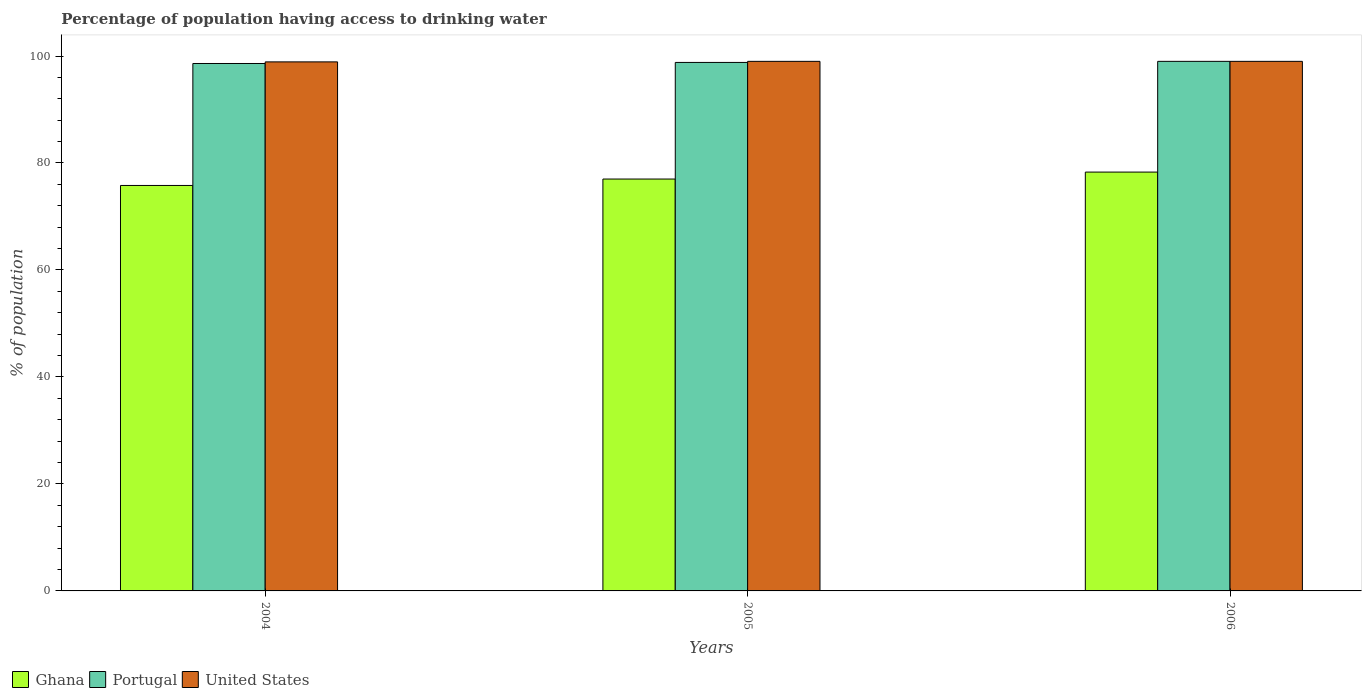How many different coloured bars are there?
Your answer should be compact. 3. How many groups of bars are there?
Your answer should be very brief. 3. Are the number of bars per tick equal to the number of legend labels?
Provide a short and direct response. Yes. How many bars are there on the 2nd tick from the right?
Ensure brevity in your answer.  3. What is the percentage of population having access to drinking water in Portugal in 2005?
Give a very brief answer. 98.8. Across all years, what is the minimum percentage of population having access to drinking water in Portugal?
Ensure brevity in your answer.  98.6. In which year was the percentage of population having access to drinking water in United States minimum?
Your response must be concise. 2004. What is the total percentage of population having access to drinking water in United States in the graph?
Your response must be concise. 296.9. What is the difference between the percentage of population having access to drinking water in United States in 2005 and that in 2006?
Make the answer very short. 0. What is the difference between the percentage of population having access to drinking water in Portugal in 2006 and the percentage of population having access to drinking water in United States in 2004?
Offer a very short reply. 0.1. What is the average percentage of population having access to drinking water in Ghana per year?
Offer a very short reply. 77.03. In the year 2005, what is the difference between the percentage of population having access to drinking water in Portugal and percentage of population having access to drinking water in United States?
Offer a terse response. -0.2. What is the ratio of the percentage of population having access to drinking water in Ghana in 2004 to that in 2005?
Offer a terse response. 0.98. Is the percentage of population having access to drinking water in Ghana in 2004 less than that in 2005?
Make the answer very short. Yes. Is the difference between the percentage of population having access to drinking water in Portugal in 2005 and 2006 greater than the difference between the percentage of population having access to drinking water in United States in 2005 and 2006?
Ensure brevity in your answer.  No. What is the difference between the highest and the second highest percentage of population having access to drinking water in United States?
Provide a short and direct response. 0. What is the difference between the highest and the lowest percentage of population having access to drinking water in Ghana?
Ensure brevity in your answer.  2.5. What does the 3rd bar from the left in 2005 represents?
Provide a short and direct response. United States. Is it the case that in every year, the sum of the percentage of population having access to drinking water in United States and percentage of population having access to drinking water in Portugal is greater than the percentage of population having access to drinking water in Ghana?
Provide a succinct answer. Yes. How many bars are there?
Provide a short and direct response. 9. How many years are there in the graph?
Your answer should be very brief. 3. What is the difference between two consecutive major ticks on the Y-axis?
Provide a short and direct response. 20. Are the values on the major ticks of Y-axis written in scientific E-notation?
Your answer should be very brief. No. Does the graph contain any zero values?
Ensure brevity in your answer.  No. Does the graph contain grids?
Provide a succinct answer. No. How many legend labels are there?
Your response must be concise. 3. How are the legend labels stacked?
Your answer should be very brief. Horizontal. What is the title of the graph?
Keep it short and to the point. Percentage of population having access to drinking water. What is the label or title of the Y-axis?
Offer a very short reply. % of population. What is the % of population in Ghana in 2004?
Your answer should be compact. 75.8. What is the % of population in Portugal in 2004?
Offer a very short reply. 98.6. What is the % of population in United States in 2004?
Provide a short and direct response. 98.9. What is the % of population in Portugal in 2005?
Provide a succinct answer. 98.8. What is the % of population in United States in 2005?
Provide a succinct answer. 99. What is the % of population of Ghana in 2006?
Your response must be concise. 78.3. What is the % of population in United States in 2006?
Your answer should be compact. 99. Across all years, what is the maximum % of population in Ghana?
Your answer should be very brief. 78.3. Across all years, what is the minimum % of population in Ghana?
Offer a very short reply. 75.8. Across all years, what is the minimum % of population in Portugal?
Your response must be concise. 98.6. Across all years, what is the minimum % of population in United States?
Offer a terse response. 98.9. What is the total % of population in Ghana in the graph?
Your answer should be compact. 231.1. What is the total % of population of Portugal in the graph?
Your answer should be compact. 296.4. What is the total % of population in United States in the graph?
Make the answer very short. 296.9. What is the difference between the % of population in Portugal in 2004 and that in 2006?
Your answer should be compact. -0.4. What is the difference between the % of population of Ghana in 2004 and the % of population of Portugal in 2005?
Ensure brevity in your answer.  -23. What is the difference between the % of population of Ghana in 2004 and the % of population of United States in 2005?
Give a very brief answer. -23.2. What is the difference between the % of population of Portugal in 2004 and the % of population of United States in 2005?
Provide a succinct answer. -0.4. What is the difference between the % of population in Ghana in 2004 and the % of population in Portugal in 2006?
Give a very brief answer. -23.2. What is the difference between the % of population in Ghana in 2004 and the % of population in United States in 2006?
Your answer should be compact. -23.2. What is the difference between the % of population in Ghana in 2005 and the % of population in United States in 2006?
Your answer should be compact. -22. What is the difference between the % of population of Portugal in 2005 and the % of population of United States in 2006?
Provide a succinct answer. -0.2. What is the average % of population of Ghana per year?
Your answer should be compact. 77.03. What is the average % of population in Portugal per year?
Ensure brevity in your answer.  98.8. What is the average % of population of United States per year?
Make the answer very short. 98.97. In the year 2004, what is the difference between the % of population in Ghana and % of population in Portugal?
Your answer should be very brief. -22.8. In the year 2004, what is the difference between the % of population in Ghana and % of population in United States?
Your answer should be compact. -23.1. In the year 2005, what is the difference between the % of population of Ghana and % of population of Portugal?
Ensure brevity in your answer.  -21.8. In the year 2005, what is the difference between the % of population in Ghana and % of population in United States?
Make the answer very short. -22. In the year 2006, what is the difference between the % of population in Ghana and % of population in Portugal?
Offer a terse response. -20.7. In the year 2006, what is the difference between the % of population of Ghana and % of population of United States?
Ensure brevity in your answer.  -20.7. In the year 2006, what is the difference between the % of population of Portugal and % of population of United States?
Provide a succinct answer. 0. What is the ratio of the % of population in Ghana in 2004 to that in 2005?
Make the answer very short. 0.98. What is the ratio of the % of population in Portugal in 2004 to that in 2005?
Your answer should be compact. 1. What is the ratio of the % of population of Ghana in 2004 to that in 2006?
Keep it short and to the point. 0.97. What is the ratio of the % of population of Portugal in 2004 to that in 2006?
Offer a terse response. 1. What is the ratio of the % of population in United States in 2004 to that in 2006?
Provide a succinct answer. 1. What is the ratio of the % of population in Ghana in 2005 to that in 2006?
Give a very brief answer. 0.98. What is the ratio of the % of population of Portugal in 2005 to that in 2006?
Give a very brief answer. 1. What is the ratio of the % of population in United States in 2005 to that in 2006?
Your answer should be very brief. 1. What is the difference between the highest and the second highest % of population of Ghana?
Provide a short and direct response. 1.3. What is the difference between the highest and the second highest % of population of Portugal?
Make the answer very short. 0.2. What is the difference between the highest and the lowest % of population of Portugal?
Make the answer very short. 0.4. 